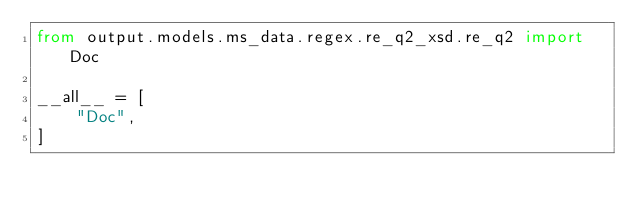<code> <loc_0><loc_0><loc_500><loc_500><_Python_>from output.models.ms_data.regex.re_q2_xsd.re_q2 import Doc

__all__ = [
    "Doc",
]
</code> 